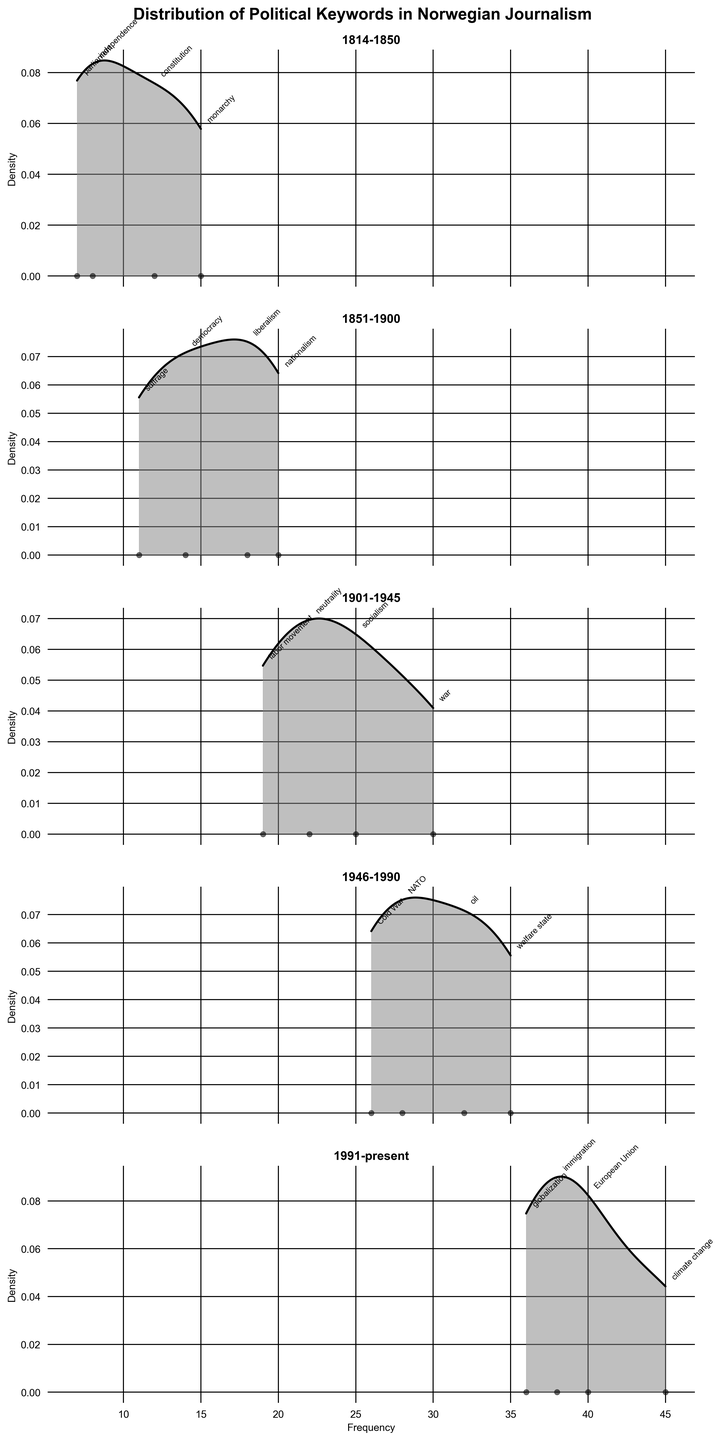What is the title of the subplot? The title of the subplot appears at the top of the figure. In this case, it reads "Distribution of Political Keywords in Norwegian Journalism".
Answer: Distribution of Political Keywords in Norwegian Journalism Which period has the highest frequency of a keyword? By examining the density plots, we see that the keyword "climate change" from the period "1991-present" has the highest frequency, 45.
Answer: 1991-present How often does the keyword "constitution" appear? The keyword "constitution" is annotated within the plot for the period "1814-1850", showing a frequency of 12.
Answer: 12 Which two periods show the highest density peaks? The highest density peaks are visible through the plot's shaded areas and curve heights. The period "1946-1990" and "1991-present" show the highest density peaks.
Answer: 1946-1990 and 1991-present What's the range of frequencies in the period "1901-1945"? The frequencies in the period "1901-1945" range from the lowest (19 for "labor movement") to the highest (30 for "war").
Answer: 19-30 Compare the frequencies of the keywords "liberalism" and "suffrage" in the period "1851-1900". Which one is higher and by how much? "Liberalism" has a frequency of 18, and "suffrage" has a frequency of 11. The difference is 18 - 11 = 7.
Answer: Liberalism by 7 Which period has the keyword with the lowest frequency, and what is that frequency? By looking at all the annotated frequencies, the period "1814-1850" has the keyword "parliament" with the lowest frequency of 7.
Answer: 1814-1850 with 7 How does the density curve of the period "1946-1990" compare to that of "1814-1850"? The density curve for "1946-1990" shows a higher peak and a more spread-out distribution compared to "1814-1850", indicating higher frequencies and more variability in the data points.
Answer: Higher peak and more spread Which period features keywords related to post-war geopolitical themes? By observing the keywords, "1946-1990" includes "NATO" and "Cold War" which are related to post-war geopolitical themes.
Answer: 1946-1990 What is the frequency of "immigration" in the period "1991-present"? The keyword "immigration" in the period "1991-present" is annotated with a frequency of 38.
Answer: 38 